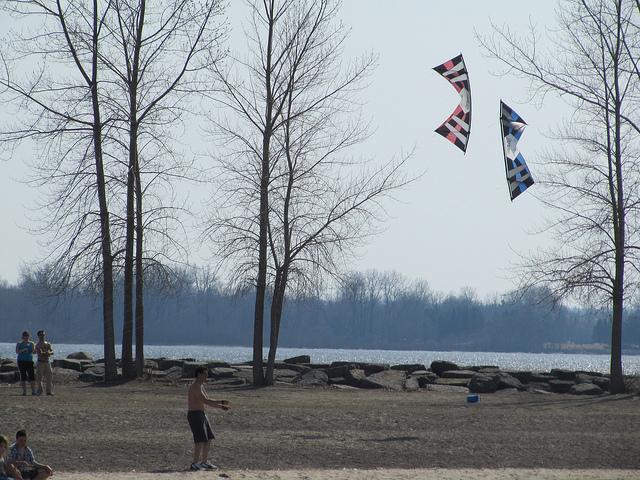How many kites are in the image?
Give a very brief answer. 2. 